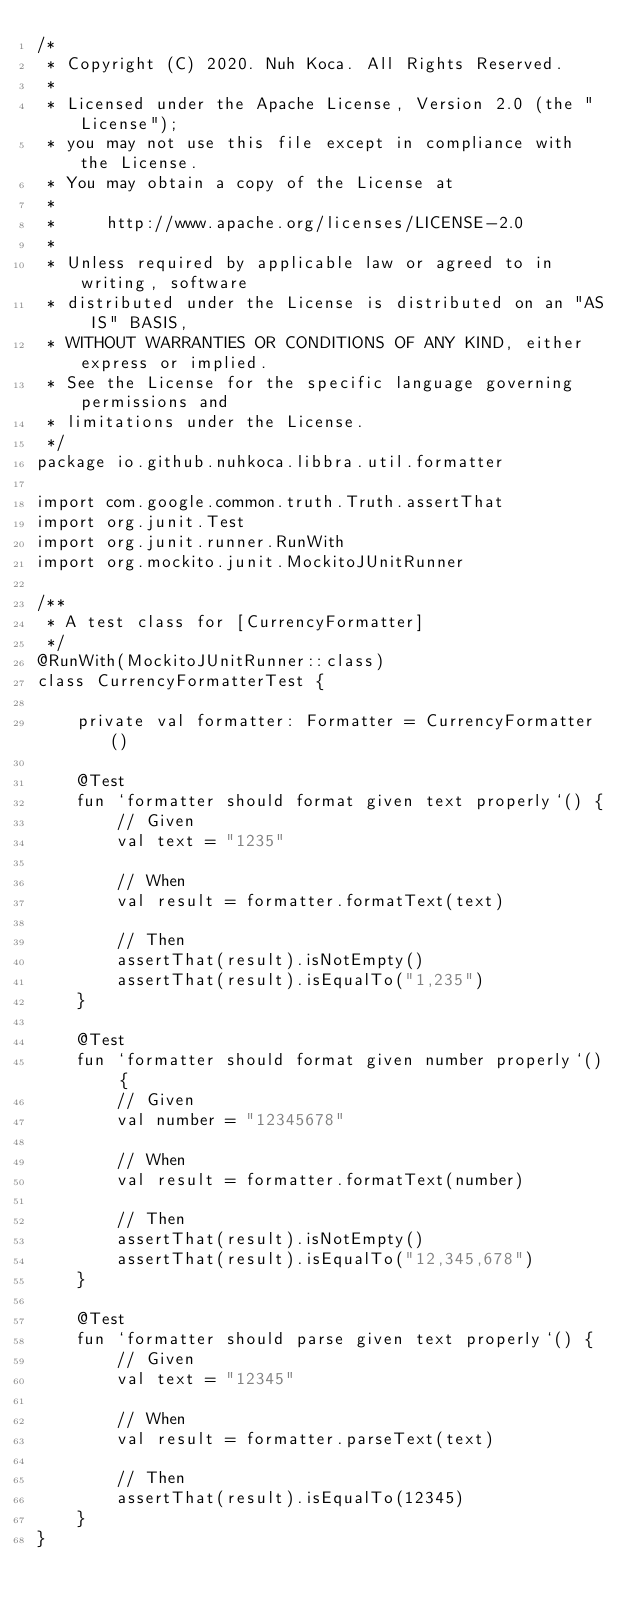<code> <loc_0><loc_0><loc_500><loc_500><_Kotlin_>/*
 * Copyright (C) 2020. Nuh Koca. All Rights Reserved.
 *
 * Licensed under the Apache License, Version 2.0 (the "License");
 * you may not use this file except in compliance with the License.
 * You may obtain a copy of the License at
 *
 *     http://www.apache.org/licenses/LICENSE-2.0
 *
 * Unless required by applicable law or agreed to in writing, software
 * distributed under the License is distributed on an "AS IS" BASIS,
 * WITHOUT WARRANTIES OR CONDITIONS OF ANY KIND, either express or implied.
 * See the License for the specific language governing permissions and
 * limitations under the License.
 */
package io.github.nuhkoca.libbra.util.formatter

import com.google.common.truth.Truth.assertThat
import org.junit.Test
import org.junit.runner.RunWith
import org.mockito.junit.MockitoJUnitRunner

/**
 * A test class for [CurrencyFormatter]
 */
@RunWith(MockitoJUnitRunner::class)
class CurrencyFormatterTest {

    private val formatter: Formatter = CurrencyFormatter()

    @Test
    fun `formatter should format given text properly`() {
        // Given
        val text = "1235"

        // When
        val result = formatter.formatText(text)

        // Then
        assertThat(result).isNotEmpty()
        assertThat(result).isEqualTo("1,235")
    }

    @Test
    fun `formatter should format given number properly`() {
        // Given
        val number = "12345678"

        // When
        val result = formatter.formatText(number)

        // Then
        assertThat(result).isNotEmpty()
        assertThat(result).isEqualTo("12,345,678")
    }

    @Test
    fun `formatter should parse given text properly`() {
        // Given
        val text = "12345"

        // When
        val result = formatter.parseText(text)

        // Then
        assertThat(result).isEqualTo(12345)
    }
}
</code> 